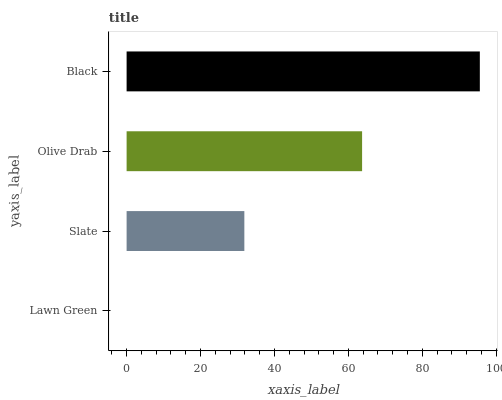Is Lawn Green the minimum?
Answer yes or no. Yes. Is Black the maximum?
Answer yes or no. Yes. Is Slate the minimum?
Answer yes or no. No. Is Slate the maximum?
Answer yes or no. No. Is Slate greater than Lawn Green?
Answer yes or no. Yes. Is Lawn Green less than Slate?
Answer yes or no. Yes. Is Lawn Green greater than Slate?
Answer yes or no. No. Is Slate less than Lawn Green?
Answer yes or no. No. Is Olive Drab the high median?
Answer yes or no. Yes. Is Slate the low median?
Answer yes or no. Yes. Is Black the high median?
Answer yes or no. No. Is Lawn Green the low median?
Answer yes or no. No. 